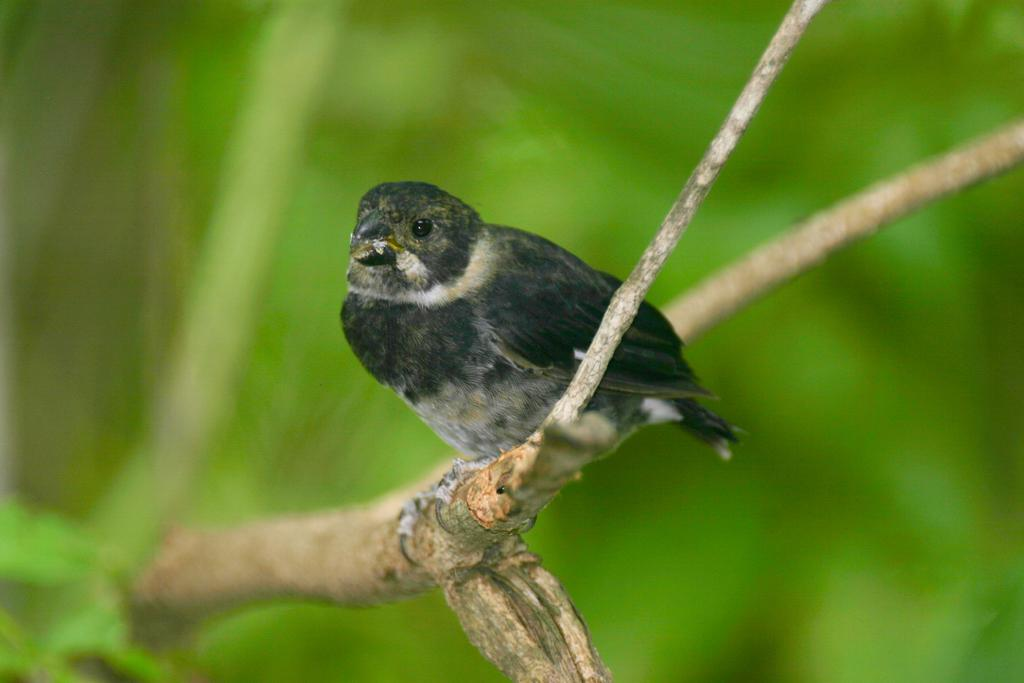What type of animal is present in the image? There is a bird in the image. Where is the bird located? The bird is on a branch. What is the color scheme of the bird? The bird is in black and white color. What color is the background of the image? The background is in green color. What type of wound can be seen on the bird's wing in the image? There is no wound visible on the bird's wing in the image, as the bird is in black and white color and no injuries are mentioned in the facts. 